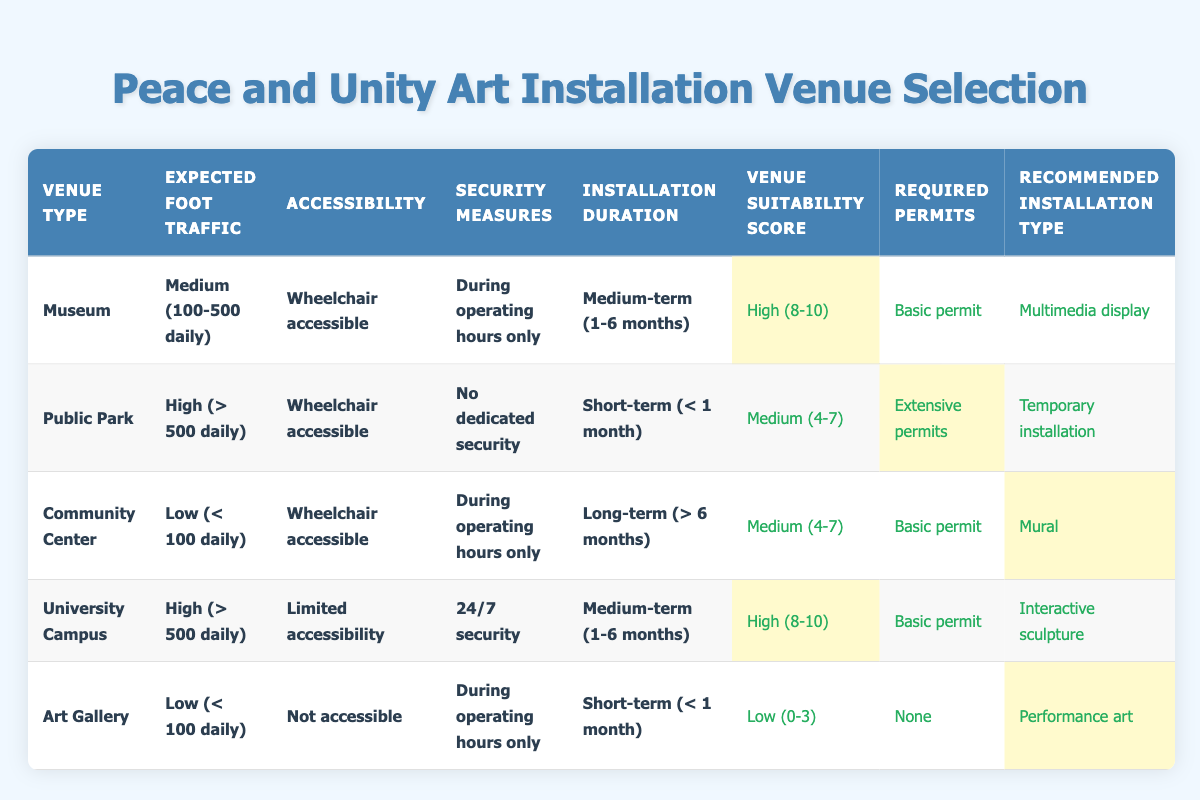What type of installation is recommended for a community center with low expected foot traffic? The row for the Community Center indicates that the recommended installation type is a mural. This is stated in the corresponding actions column for the defined conditions of "Low (< 100 daily)" foot traffic, "Wheelchair accessible," "During operating hours only," and "Long-term (> 6 months)."
Answer: Mural Is a public park suitable for high foot traffic art installations? The Public Park row shows that it can accommodate high foot traffic (> 500 daily), but the suitability score is medium (4-7). Thus, while it is suitable for high foot traffic, it's not rated as highly suitable which suggests some limitations.
Answer: Yes What security measures are in place for an installation at a university campus? The row for the University Campus states that 24/7 security is the security measure available for the installation. This should ensure a safe environment for the art installation.
Answer: 24/7 security Which venue has the lowest venue suitability score and what is that score? The Art Gallery row indicates that it has the lowest suitability score, which is low (0-3). This is determined by its conditions including low foot traffic and limited accessibility.
Answer: Low (0-3) Are extensive permits required for a temporary installation in a public park? The Public Park row indicates that extensive permits are indeed required for the temporary installation under conditions of high foot traffic and no dedicated security.
Answer: Yes What is the average venue suitability score for installations in museums and university campuses? The museum has a suitability score of high (8-10) and the university campus also has high (8-10). Averaging these scores translates into a numeric value (8+9)/2 = 8.5 since both qualify under the high criteria.
Answer: 8.5 In which venue can an interactive sculpture be installed, and what permits are required? The University Campus is the only venue that recommends an interactive sculpture with a basic permit required for the installation under certain conditions. This can be checked by referencing specific attributes in the university campus row.
Answer: University Campus, Basic permit What is the installation duration for a performance art in an art gallery? The Art Gallery row indicates that performance art is recommended for a short-term installation (< 1 month). This can be directly found in the row corresponding to the Art Gallery's conditions.
Answer: Short-term (< 1 month) 